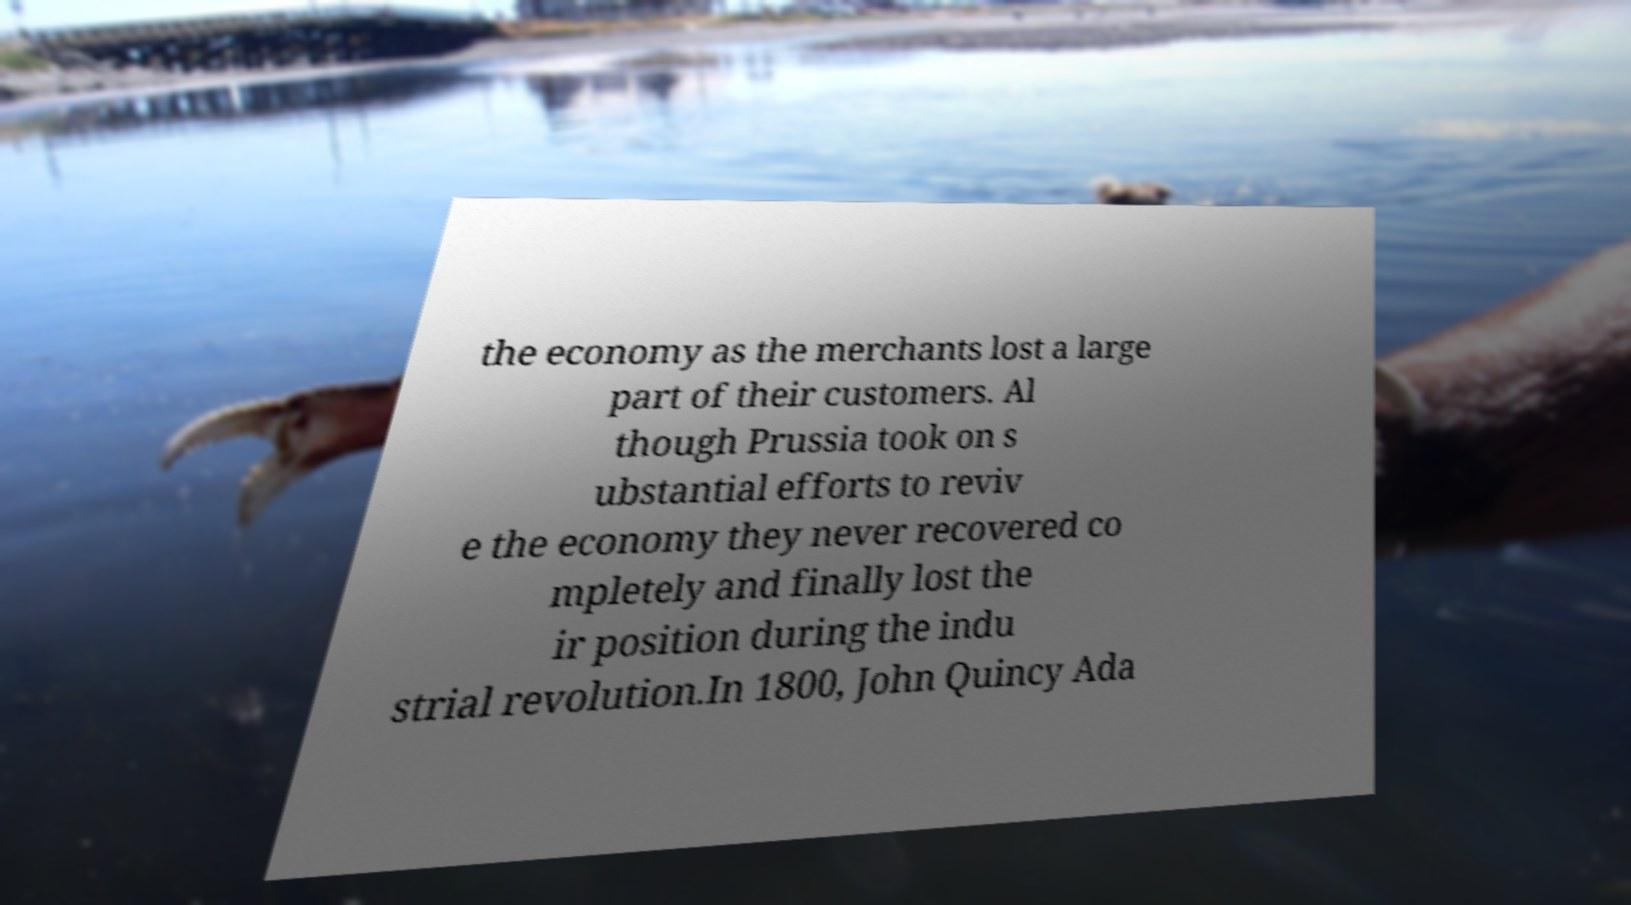Can you accurately transcribe the text from the provided image for me? the economy as the merchants lost a large part of their customers. Al though Prussia took on s ubstantial efforts to reviv e the economy they never recovered co mpletely and finally lost the ir position during the indu strial revolution.In 1800, John Quincy Ada 